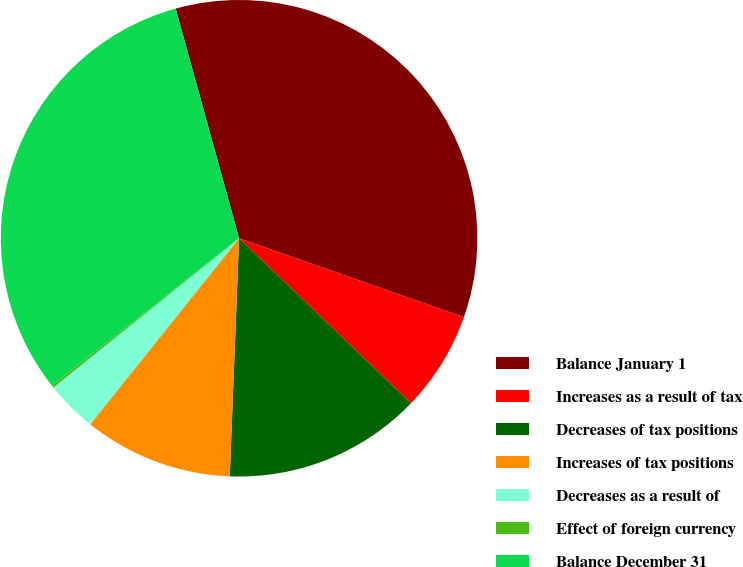Convert chart. <chart><loc_0><loc_0><loc_500><loc_500><pie_chart><fcel>Balance January 1<fcel>Increases as a result of tax<fcel>Decreases of tax positions<fcel>Increases of tax positions<fcel>Decreases as a result of<fcel>Effect of foreign currency<fcel>Balance December 31<nl><fcel>34.66%<fcel>6.8%<fcel>13.45%<fcel>10.12%<fcel>3.48%<fcel>0.16%<fcel>31.33%<nl></chart> 